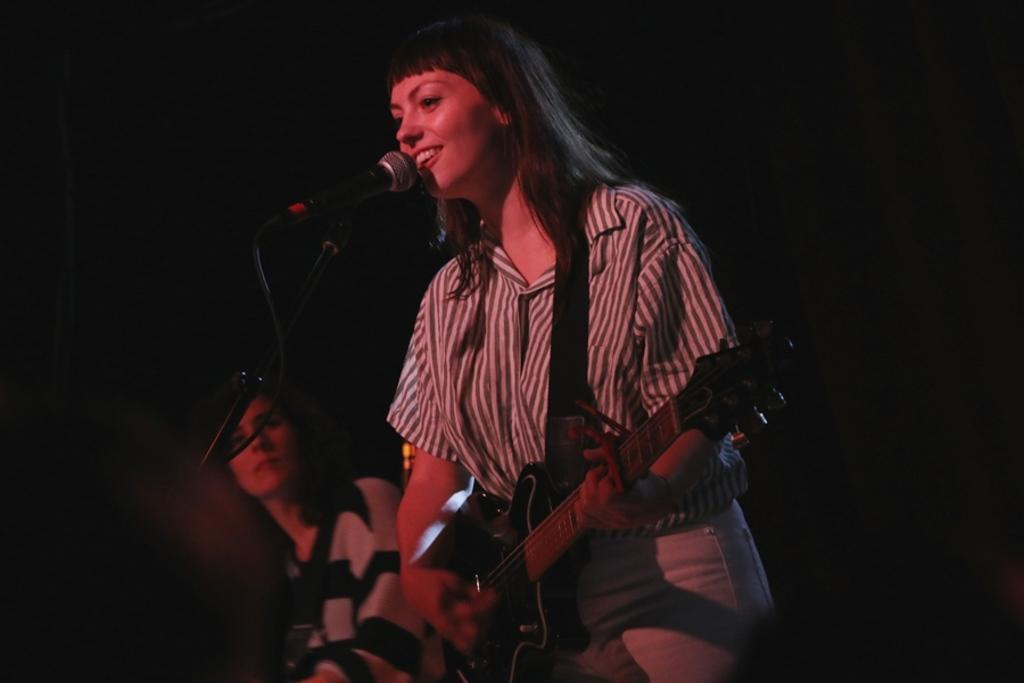What is the main subject of the image? There is a woman standing in the center of the image. What is the woman in the center doing? The woman is holding a guitar in her hand and singing on a microphone. Are there any other people in the image? Yes, there is another woman on the left side of the image. How many apples are on the microphone in the image? There are no apples present in the image, and therefore none can be found on the microphone. What is the level of fear expressed by the woman holding the guitar in the image? The image does not provide any information about the woman's emotions or level of fear. 